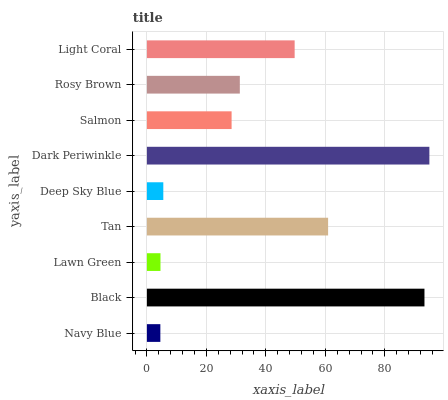Is Navy Blue the minimum?
Answer yes or no. Yes. Is Dark Periwinkle the maximum?
Answer yes or no. Yes. Is Black the minimum?
Answer yes or no. No. Is Black the maximum?
Answer yes or no. No. Is Black greater than Navy Blue?
Answer yes or no. Yes. Is Navy Blue less than Black?
Answer yes or no. Yes. Is Navy Blue greater than Black?
Answer yes or no. No. Is Black less than Navy Blue?
Answer yes or no. No. Is Rosy Brown the high median?
Answer yes or no. Yes. Is Rosy Brown the low median?
Answer yes or no. Yes. Is Navy Blue the high median?
Answer yes or no. No. Is Black the low median?
Answer yes or no. No. 